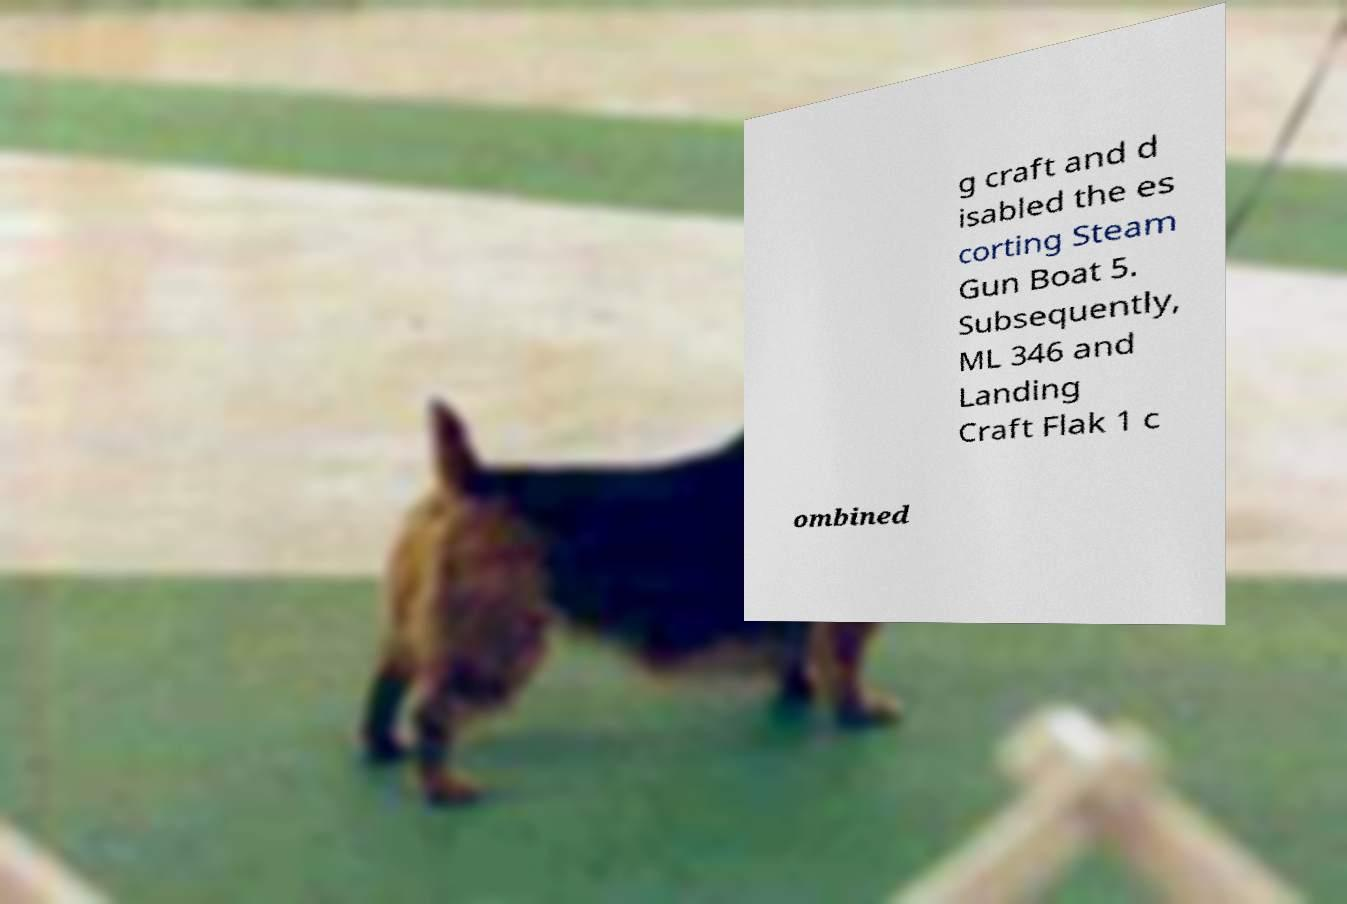I need the written content from this picture converted into text. Can you do that? g craft and d isabled the es corting Steam Gun Boat 5. Subsequently, ML 346 and Landing Craft Flak 1 c ombined 